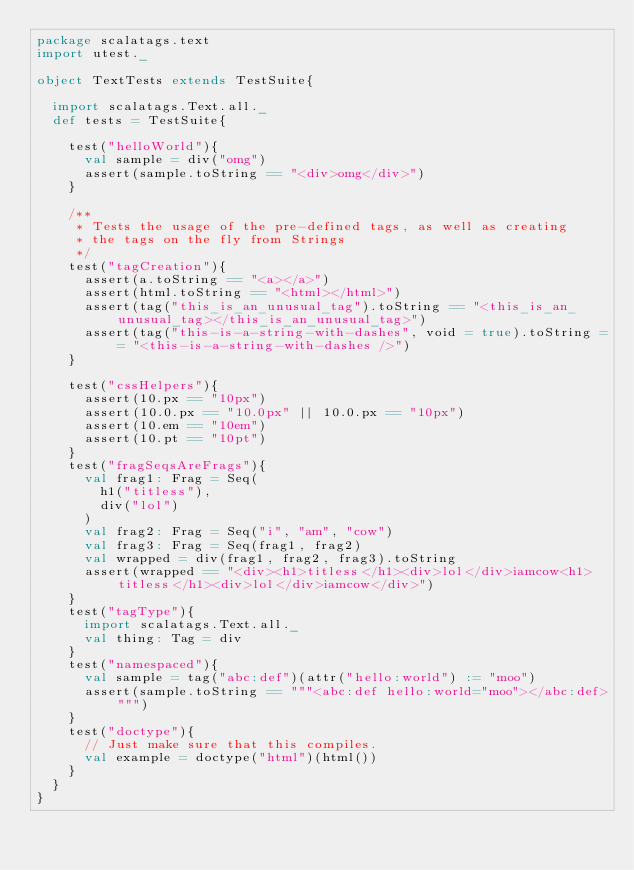Convert code to text. <code><loc_0><loc_0><loc_500><loc_500><_Scala_>package scalatags.text
import utest._

object TextTests extends TestSuite{

  import scalatags.Text.all._
  def tests = TestSuite{

    test("helloWorld"){
      val sample = div("omg")
      assert(sample.toString == "<div>omg</div>")
    }

    /**
     * Tests the usage of the pre-defined tags, as well as creating
     * the tags on the fly from Strings
     */
    test("tagCreation"){
      assert(a.toString == "<a></a>")
      assert(html.toString == "<html></html>")
      assert(tag("this_is_an_unusual_tag").toString == "<this_is_an_unusual_tag></this_is_an_unusual_tag>")
      assert(tag("this-is-a-string-with-dashes", void = true).toString == "<this-is-a-string-with-dashes />")
    }

    test("cssHelpers"){
      assert(10.px == "10px")
      assert(10.0.px == "10.0px" || 10.0.px == "10px")
      assert(10.em == "10em")
      assert(10.pt == "10pt")
    }
    test("fragSeqsAreFrags"){
      val frag1: Frag = Seq(
        h1("titless"),
        div("lol")
      )
      val frag2: Frag = Seq("i", "am", "cow")
      val frag3: Frag = Seq(frag1, frag2)
      val wrapped = div(frag1, frag2, frag3).toString
      assert(wrapped == "<div><h1>titless</h1><div>lol</div>iamcow<h1>titless</h1><div>lol</div>iamcow</div>")
    }
    test("tagType"){
      import scalatags.Text.all._
      val thing: Tag = div
    }
    test("namespaced"){
      val sample = tag("abc:def")(attr("hello:world") := "moo")
      assert(sample.toString == """<abc:def hello:world="moo"></abc:def>""")
    }
    test("doctype"){
      // Just make sure that this compiles.
      val example = doctype("html")(html())
    }
  }
}
</code> 